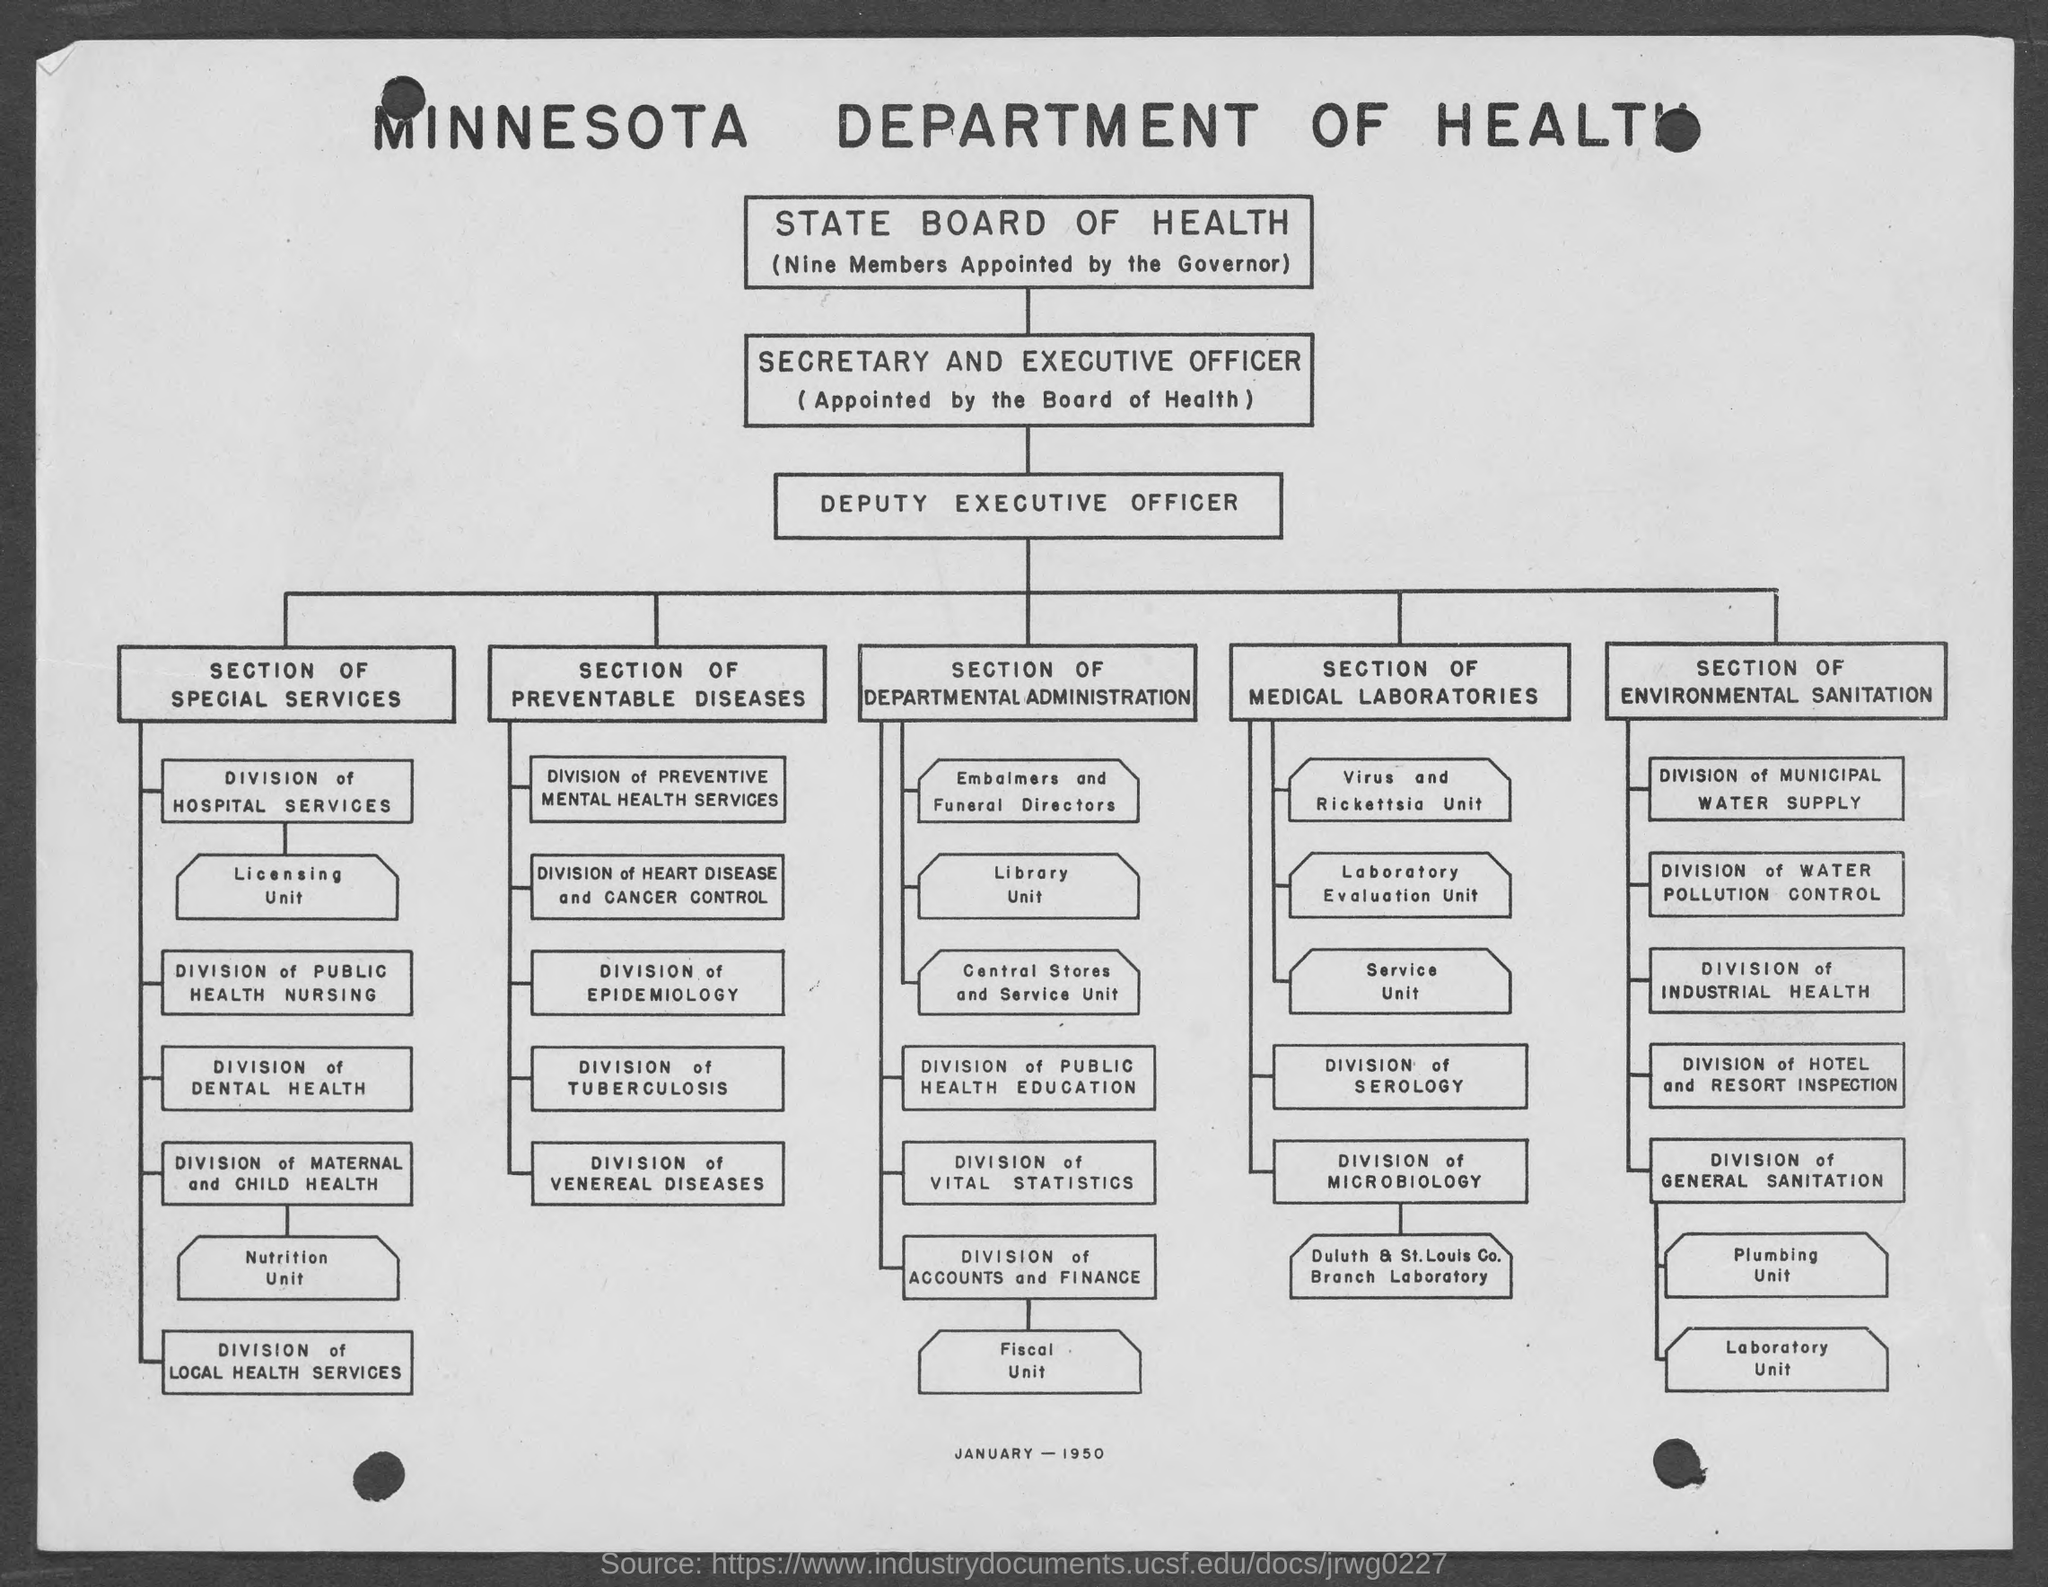Point out several critical features in this image. Division of Dental Health falls under the Section of Special Services. The governor appoints nine members to the state board of health. The Secretary and Executive Officer are appointed by the Board of Health. The document mentions the "Minnesota Department of Health". The flowchart is for the month and year of January 1950. 